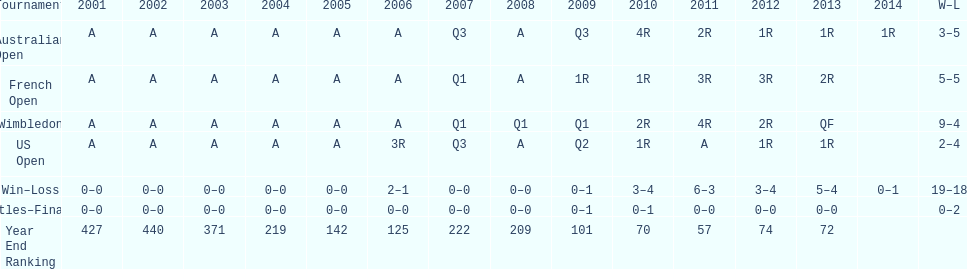In which years were there only 1 loss? 2006, 2009, 2014. 